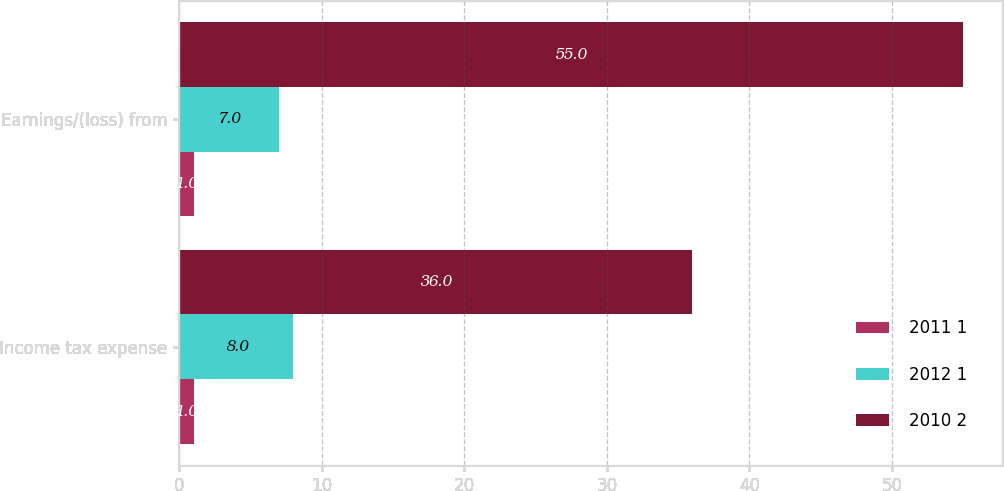Convert chart to OTSL. <chart><loc_0><loc_0><loc_500><loc_500><stacked_bar_chart><ecel><fcel>Income tax expense<fcel>Earnings/(loss) from<nl><fcel>2011 1<fcel>1<fcel>1<nl><fcel>2012 1<fcel>8<fcel>7<nl><fcel>2010 2<fcel>36<fcel>55<nl></chart> 